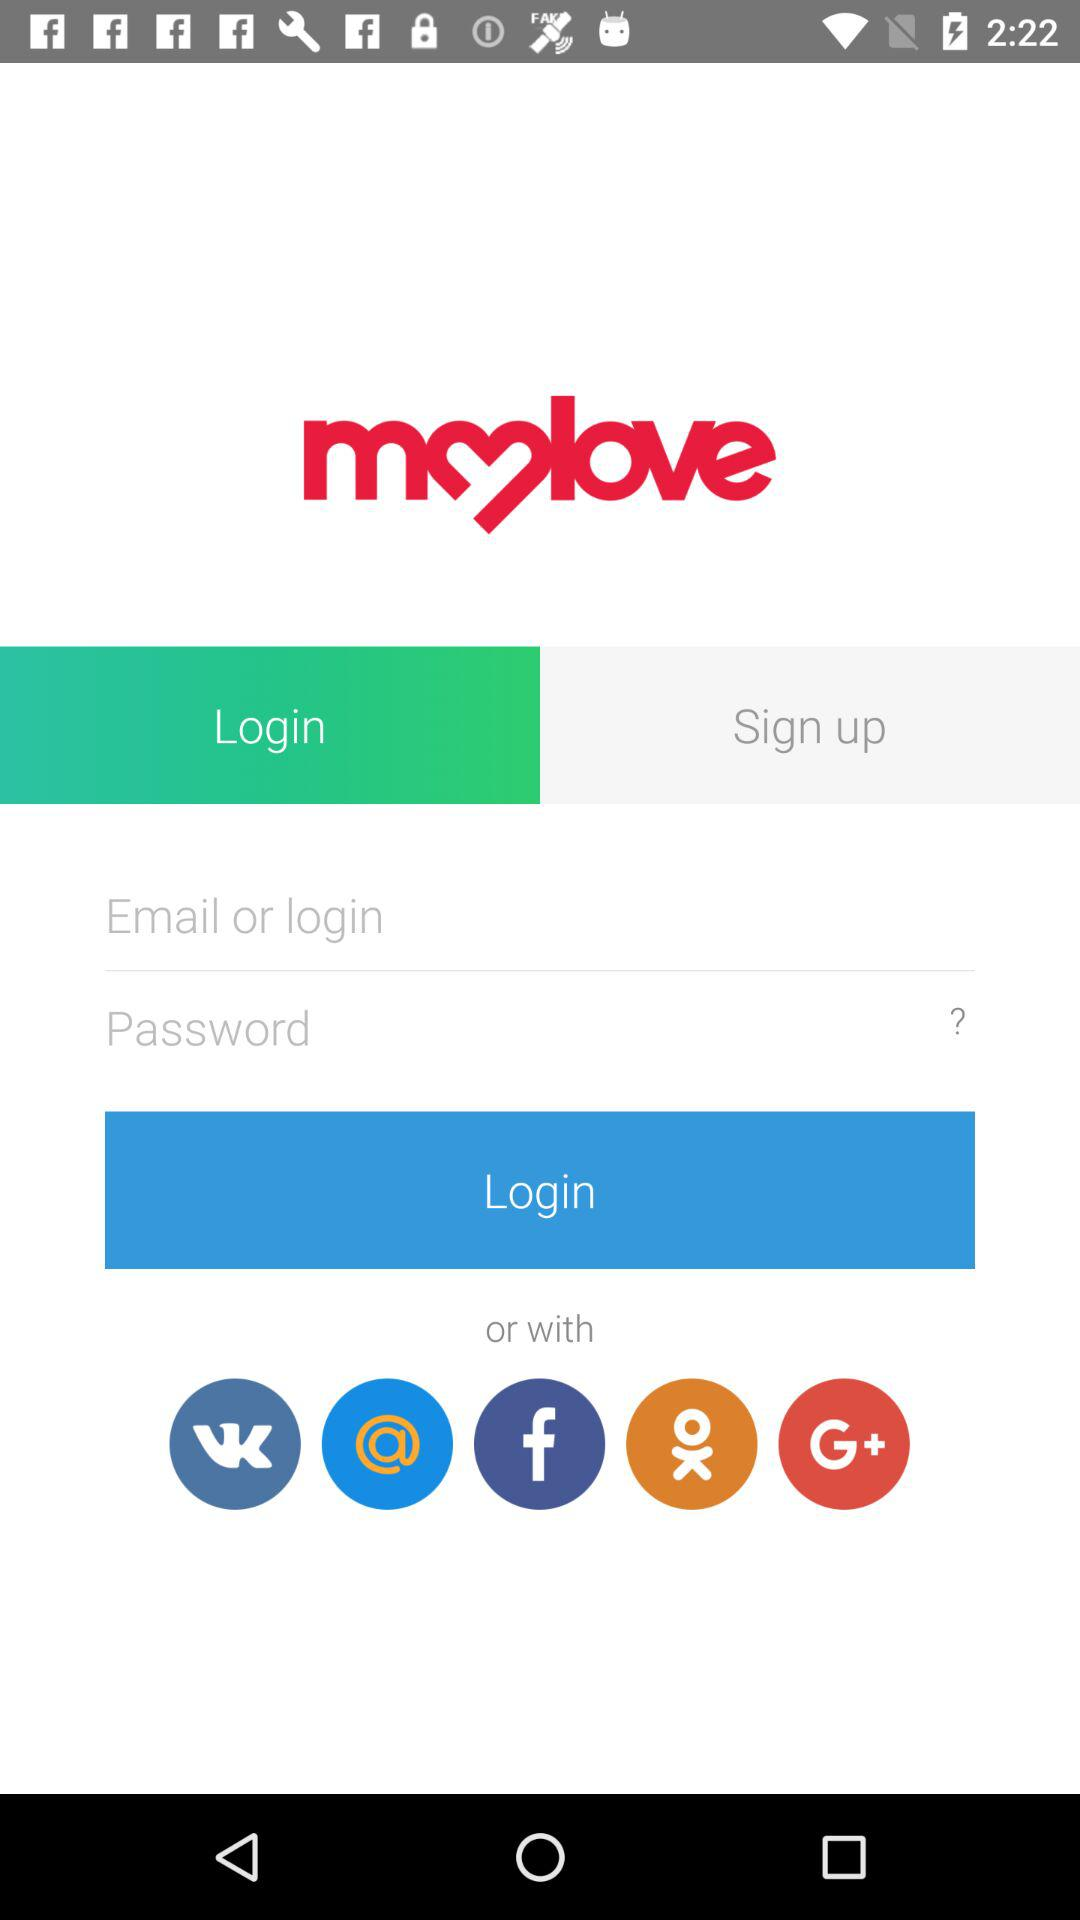How many social media login options are there?
Answer the question using a single word or phrase. 5 